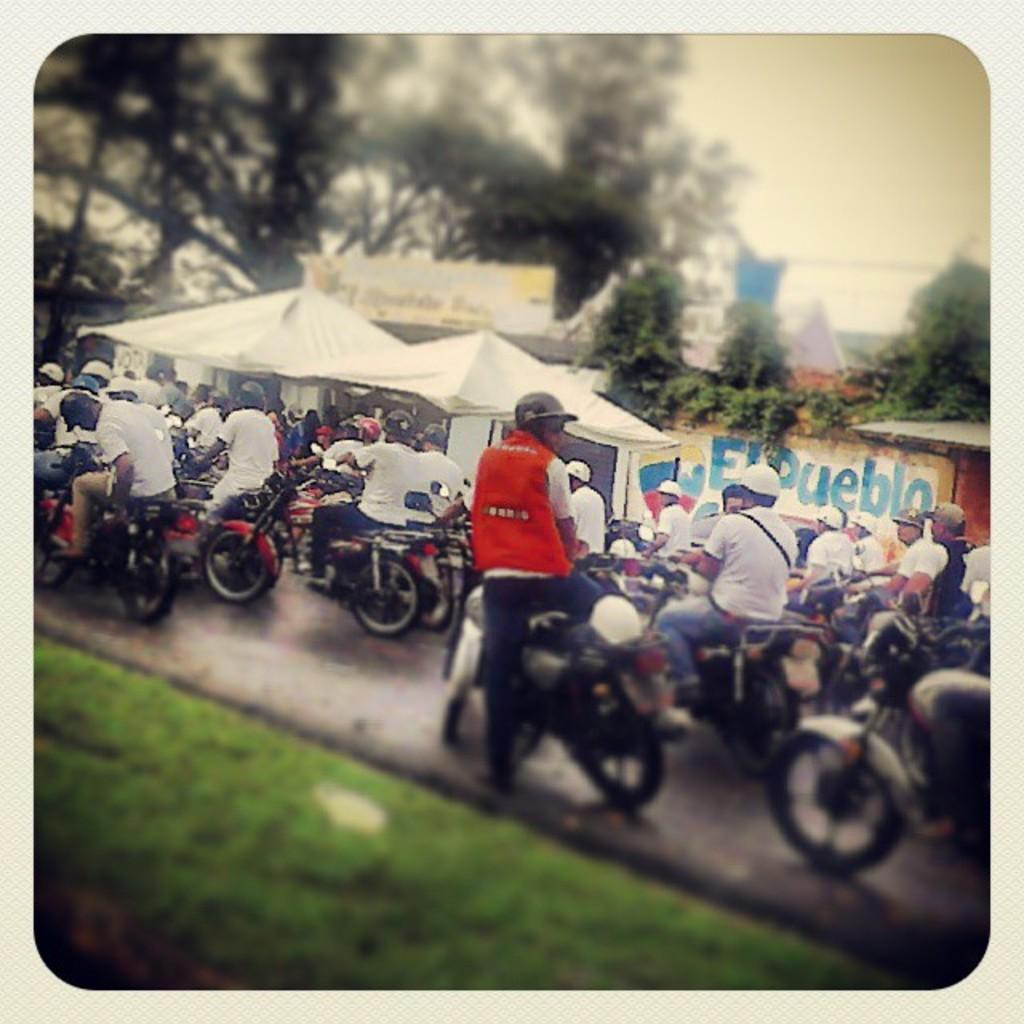What are the people in the image doing? The people in the image are riding bikes. How are the bikes arranged in the image? The people are riding bikes one after the other. What can be seen in the background of the image? There are trees, a banner, and the sky visible in the background of the image. What type of terrain is visible in the image? There is grass in the image. How many cattle can be seen grazing in the image? There are no cattle present in the image. What type of seat is available for the people riding bikes in the image? The bikes in the image have built-in seats for the riders; there is no separate seat mentioned or visible. 